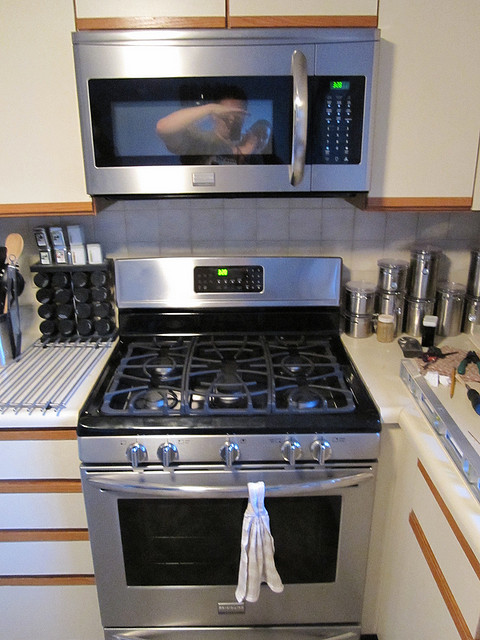How many people are reflected in the microwave window? There is one person visible in the reflection on the microwave window, who appears to be taking the photograph. 